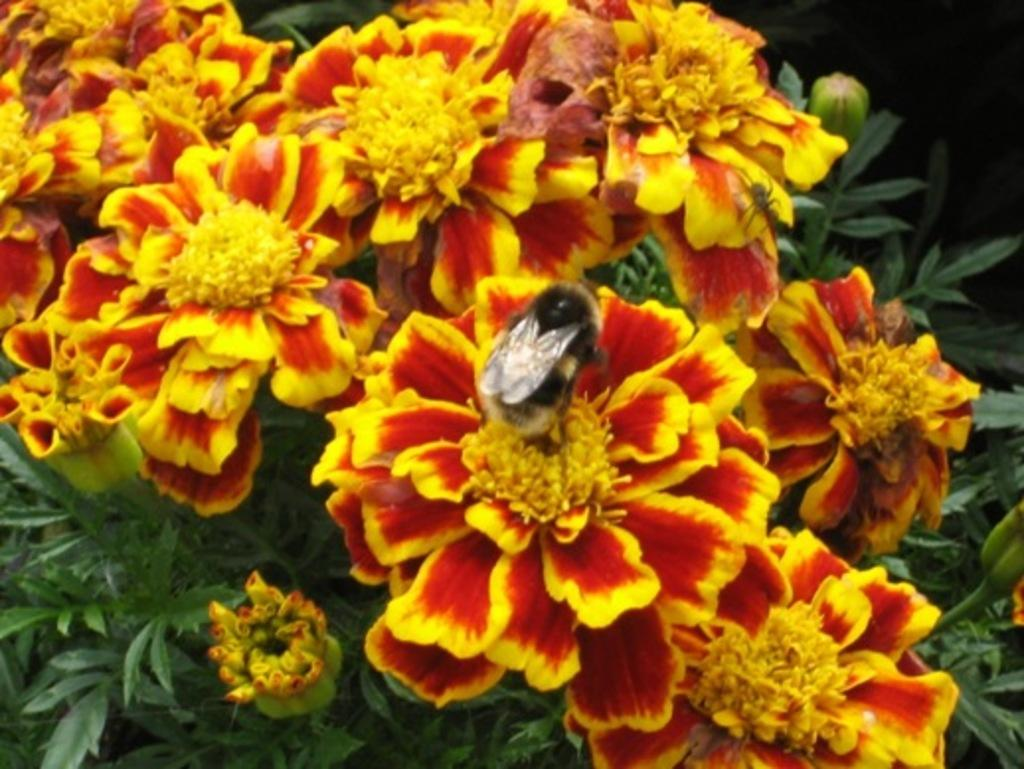What is present in the image? There is a plant in the image. Can you describe the flowers on the plant? The plant has yellow and red color flowers. Is there anything else present on the plant? Yes, there is an insect on one of the flowers. How many fingers can be seen holding the balls in the image? There are no fingers or balls present in the image; it features a plant with flowers and an insect. 